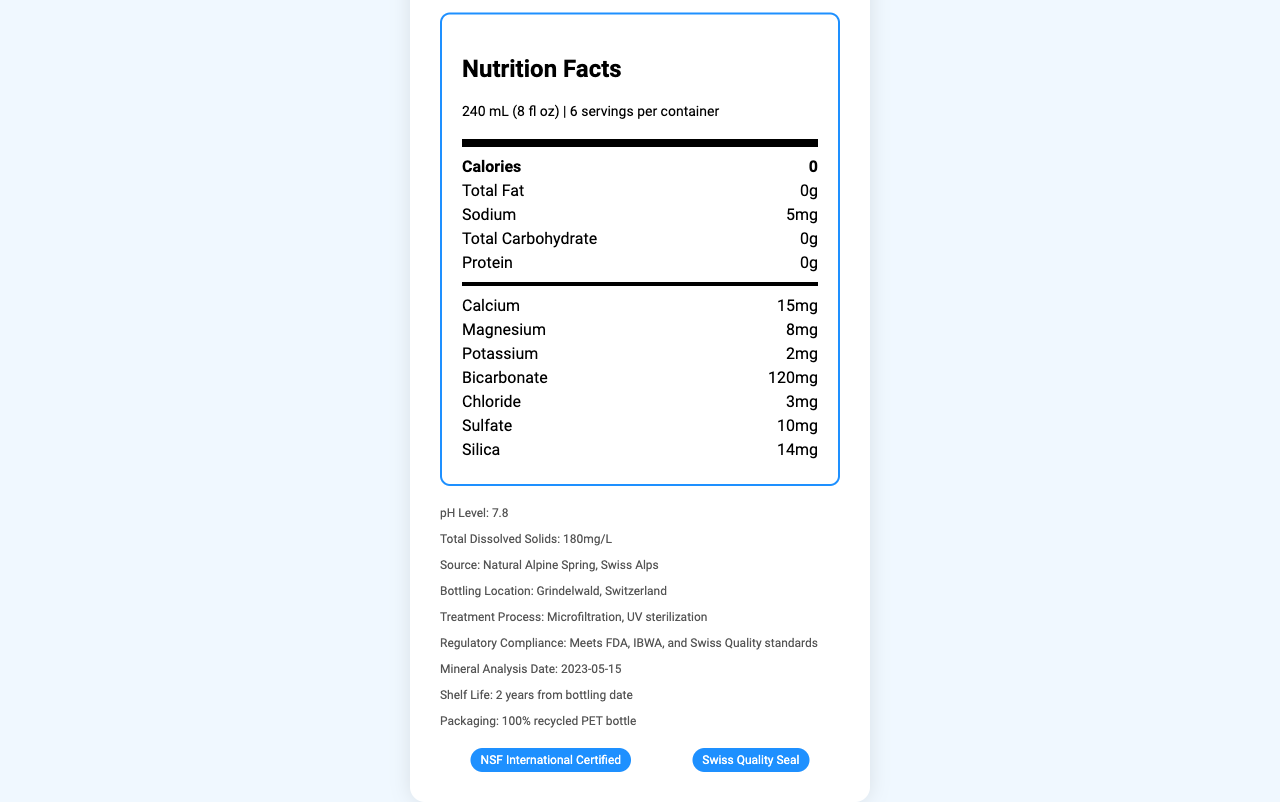what is the serving size? The serving size is clearly mentioned in the document under the "serving size" section as 240 mL (8 fl oz).
Answer: 240 mL (8 fl oz) how many servings are there per container? The number of servings per container is listed as 6.
Answer: 6 what is the sodium content in one serving? The sodium content per serving is stated as 5mg in the document.
Answer: 5mg what is the bottling location? The bottling location is specified as Grindelwald, Switzerland.
Answer: Grindelwald, Switzerland what health claims are associated with this water? The health claims listed are "Naturally occurring electrolytes", "Low sodium content", and "Helps maintain hydration".
Answer: Naturally occurring electrolytes, Low sodium content, Helps maintain hydration how much calcium is present per serving? The calcium content is listed as 15mg per serving.
Answer: 15mg what is the pH level of the water? The pH level is indicated on the document as 7.8.
Answer: 7.8 which mineral is present in the highest amount? A. Magnesium B. Silica C. Bicarbonate D. Calcium The document lists bicarbonate as having 120mg per serving, which is the highest among the listed minerals.
Answer: C. Bicarbonate what is the treatment process used for this water? A. Microfiltration and UV sterilization B. Distillation and Reverse Osmosis C. Chlorination and Deionization The treatment process is detailed as Microfiltration and UV sterilization.
Answer: A. Microfiltration and UV sterilization is the product packaged in recycled materials? The document states that the packaging is in 100% recycled PET bottle.
Answer: Yes does this water product meet any regulatory standards? The document mentions that it meets FDA, IBWA, and Swiss Quality standards.
Answer: Yes describe the main features of the Alpine Pure Spring Water as seen in the document. This answer summarizes the key points mentioned in the document regarding mineral content, source, bottling location, treatment process, regulatory compliance, and packaging.
Answer: Alpine Pure Spring Water is sourced from a natural spring in the Swiss Alps and is bottled in Grindelwald, Switzerland. It undergoes microfiltration and UV sterilization and meets several regulatory standards. It contains essential minerals such as bicarbonate, calcium, and magnesium, with a pH level of 7.8 and low sodium content, making it a good option for hydration. The packaging is environmentally friendly, made from 100% recycled PET bottles. when was the mineral analysis of the water done? The document states that the mineral analysis was done on 2023-05-15.
Answer: 2023-05-15 what is the total dissolved solids content of this water? The document lists the total dissolved solids (TDS) as 180mg/L.
Answer: 180mg/L what organization certified this product? A. NSF International B. Swiss Quality Seal C. Both A and B The document mentions both "NSF International Certified" and "Swiss Quality Seal" as certifications.
Answer: C. Both A and B how much silica is in the water? The silica content as mentioned in the document is 14mg per serving.
Answer: 14mg what natural feature is this water sourced from? The document indicates that the source of the water is a natural Alpine Spring in the Swiss Alps.
Answer: Natural Alpine Spring, Swiss Alps how is the regulatory compliance of this water described? The document states that the water meets FDA, IBWA, and Swiss Quality standards.
Answer: Meets FDA, IBWA, and Swiss Quality standards can the mineral content of the water change over time? The document does not provide information on whether the mineral content can change over time.
Answer: Cannot be determined 